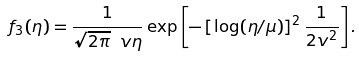Convert formula to latex. <formula><loc_0><loc_0><loc_500><loc_500>f _ { 3 } ( \eta ) = \frac { 1 } { \sqrt { 2 \pi } \ v \eta } \exp \left [ - \left [ \log ( \eta / \mu ) \right ] ^ { 2 } \frac { 1 } { 2 v ^ { 2 } } \right ] .</formula> 